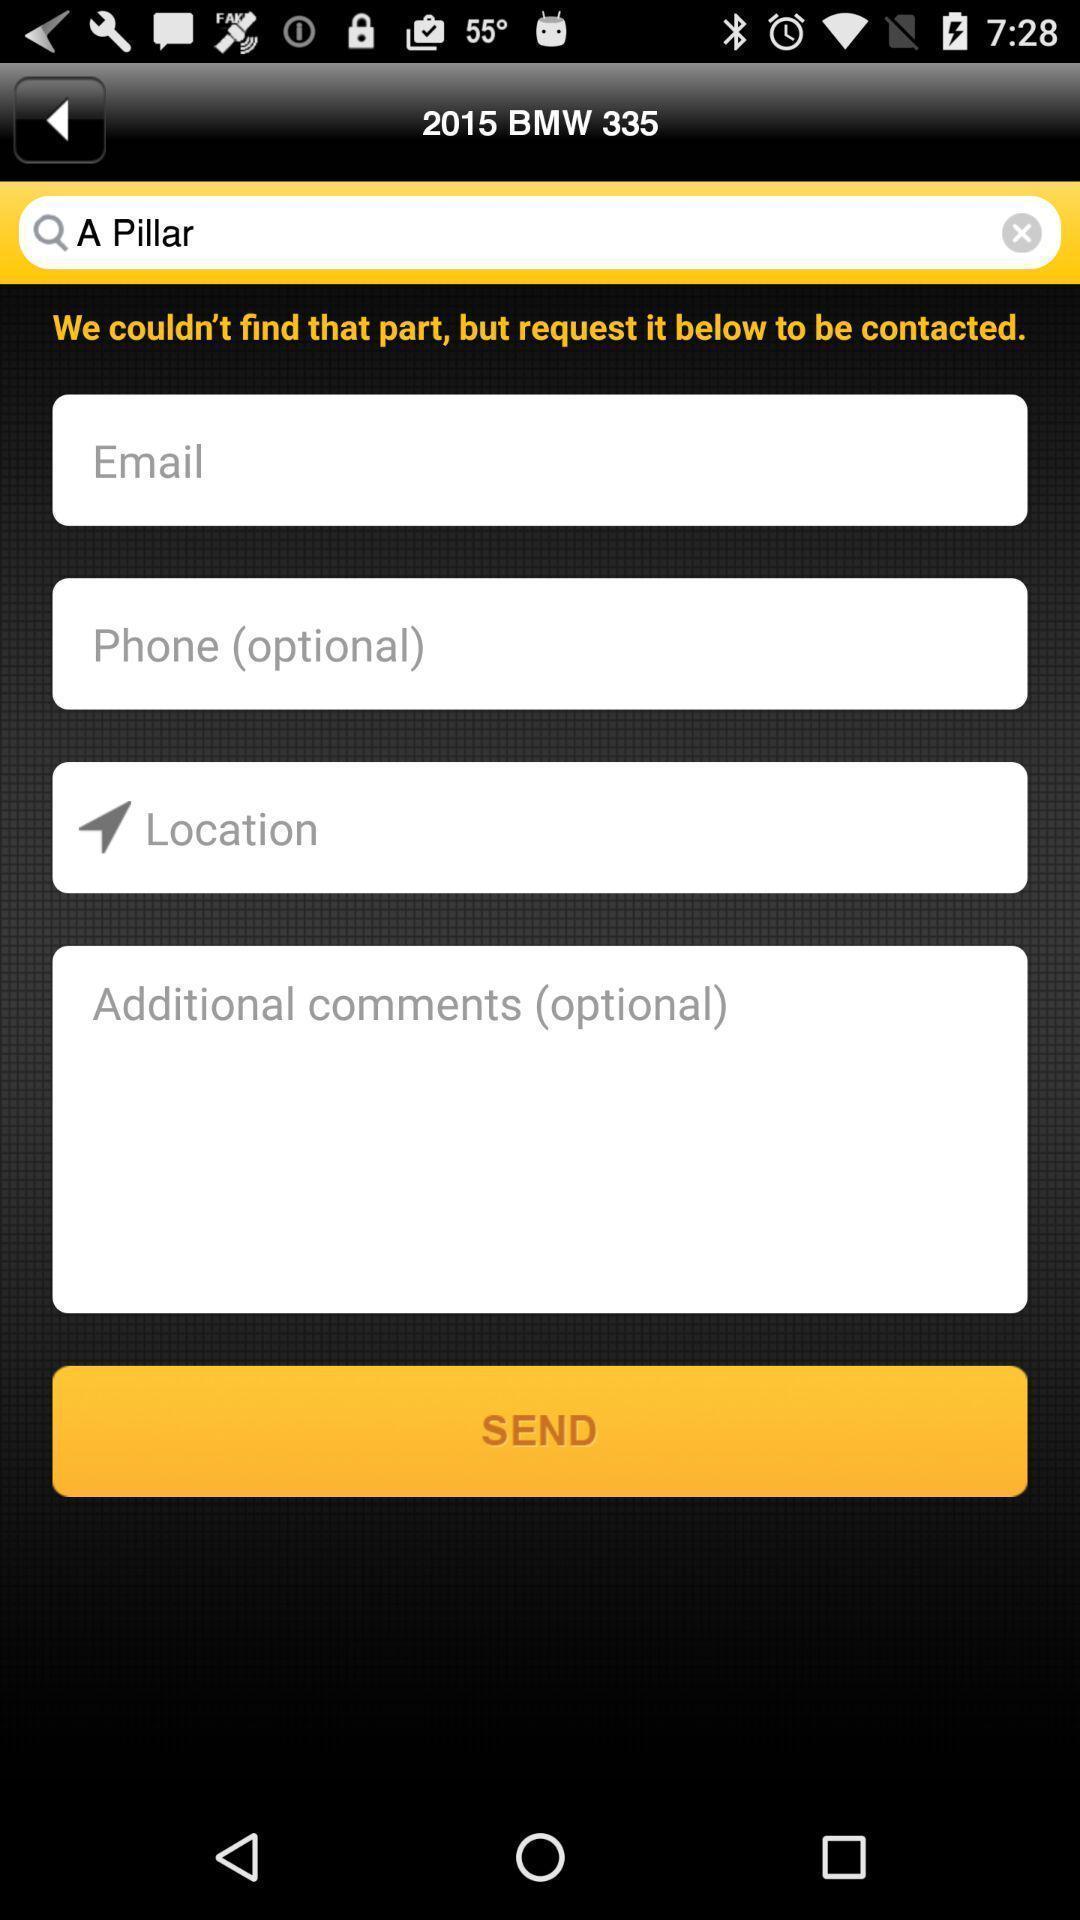Give me a summary of this screen capture. Screen showing search bar with contact details to fill. 